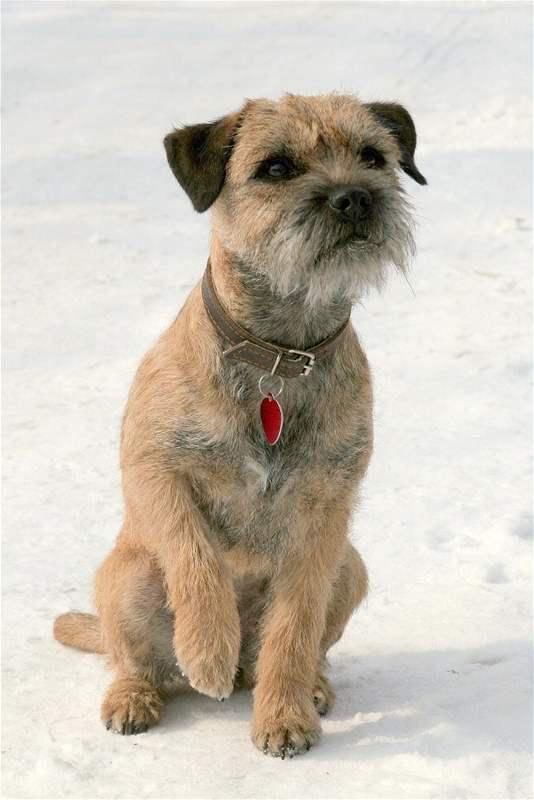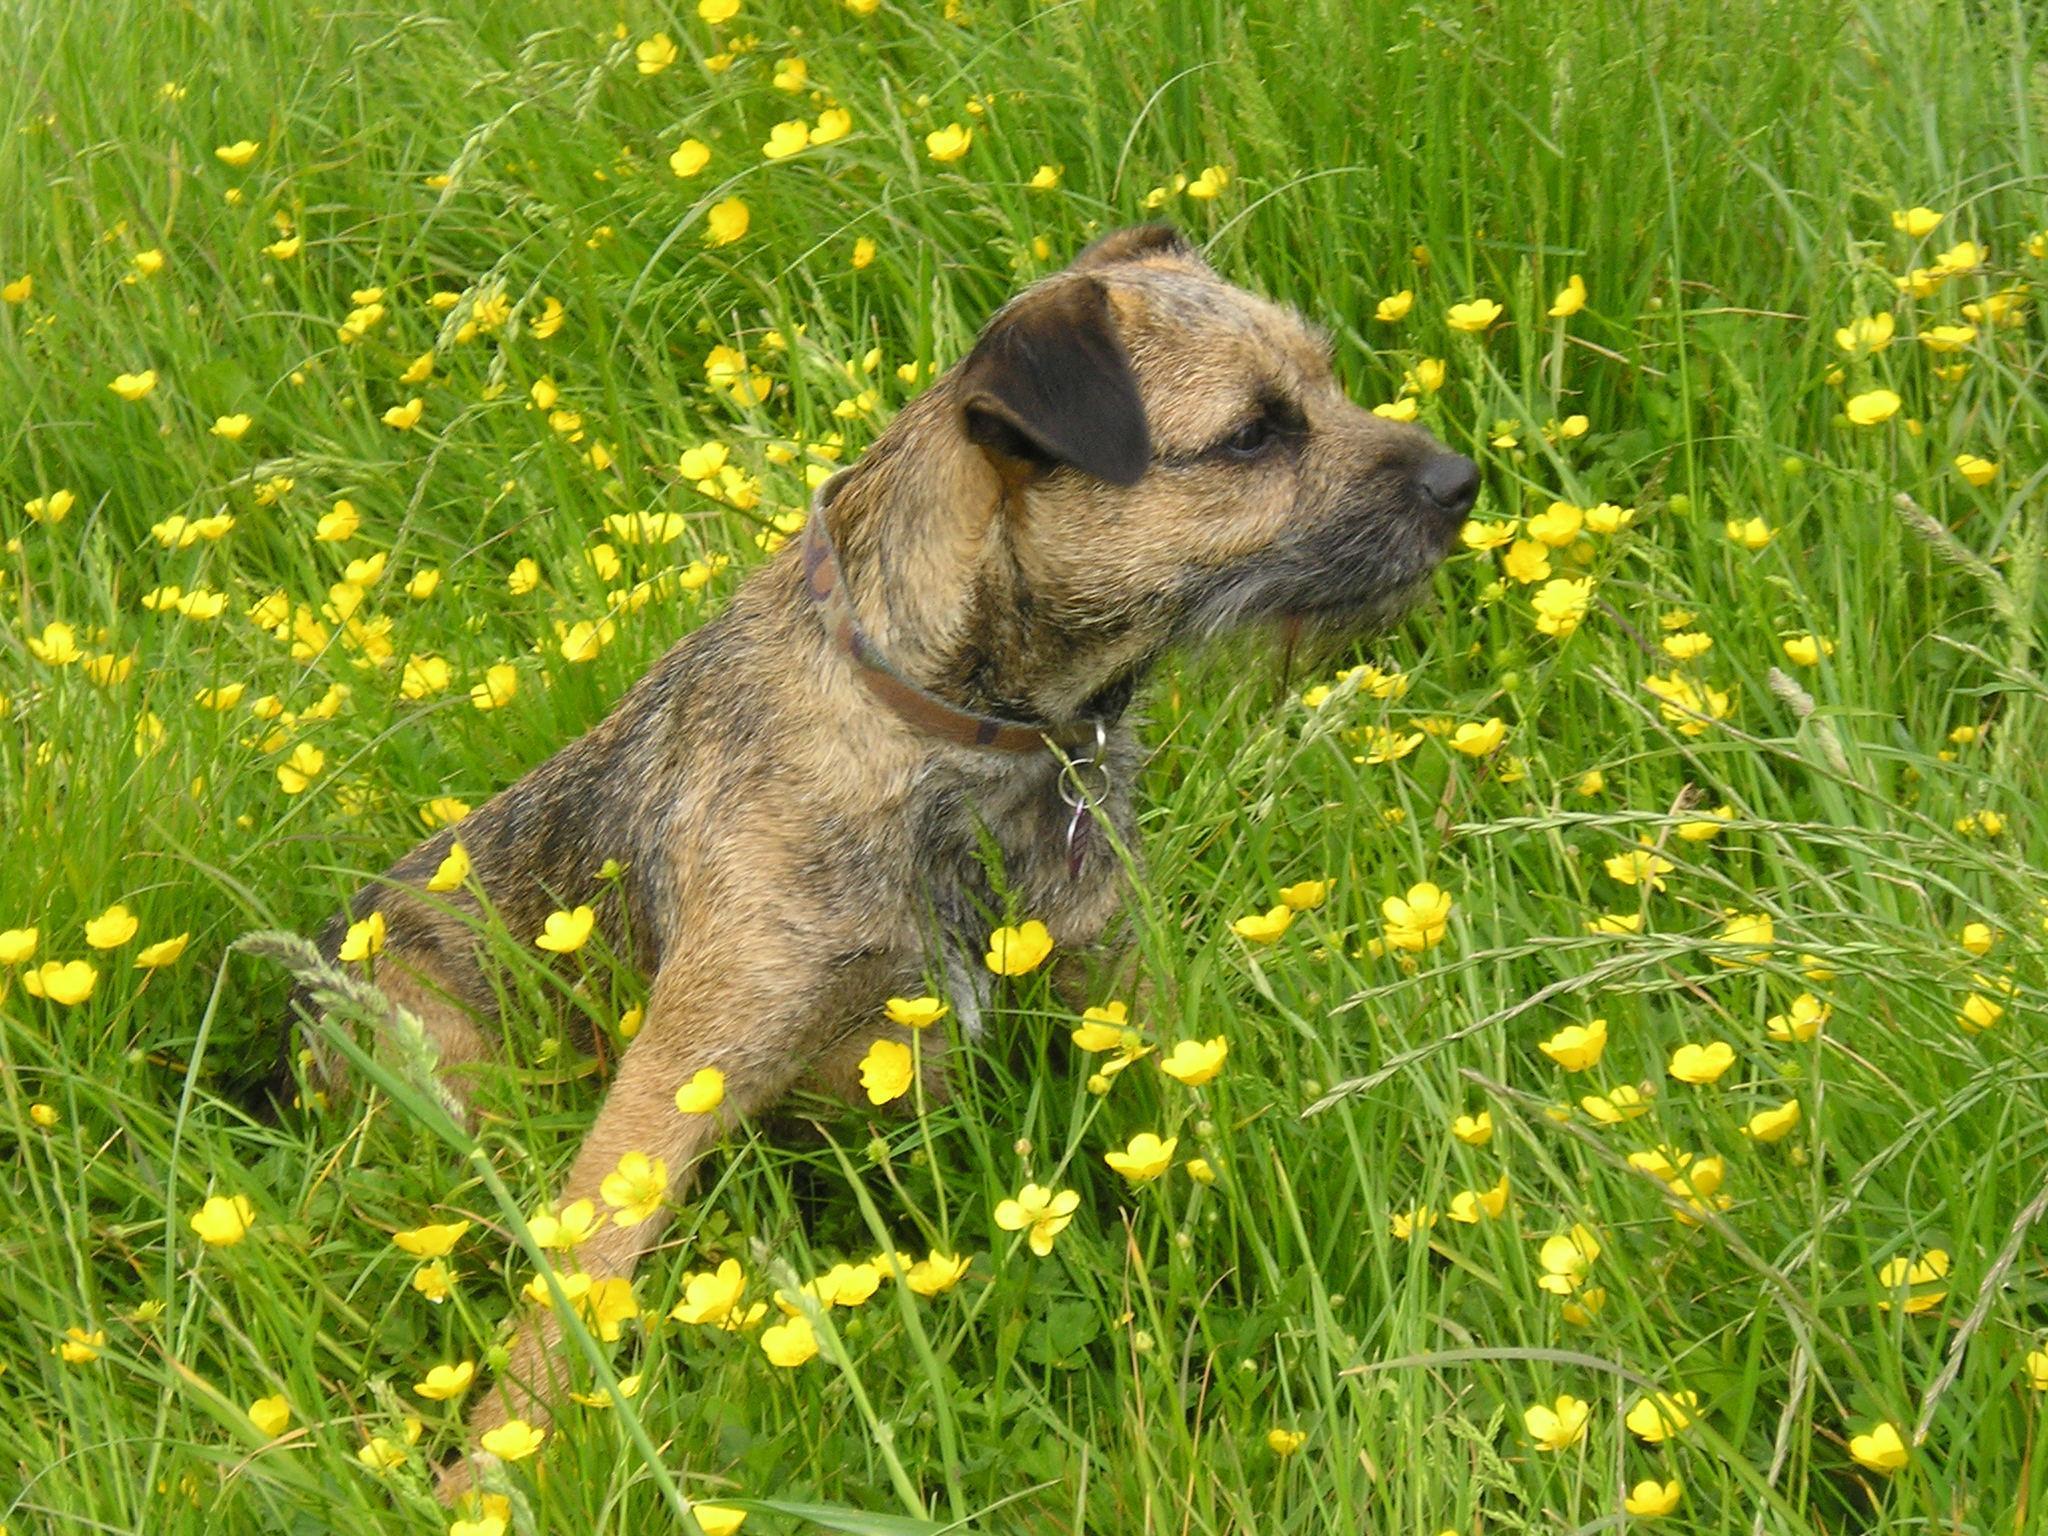The first image is the image on the left, the second image is the image on the right. For the images shown, is this caption "One of the pictures has a dog carrying another animal in its mouth." true? Answer yes or no. No. The first image is the image on the left, the second image is the image on the right. Examine the images to the left and right. Is the description "a dog is carrying a dead animal in it's mouth" accurate? Answer yes or no. No. 